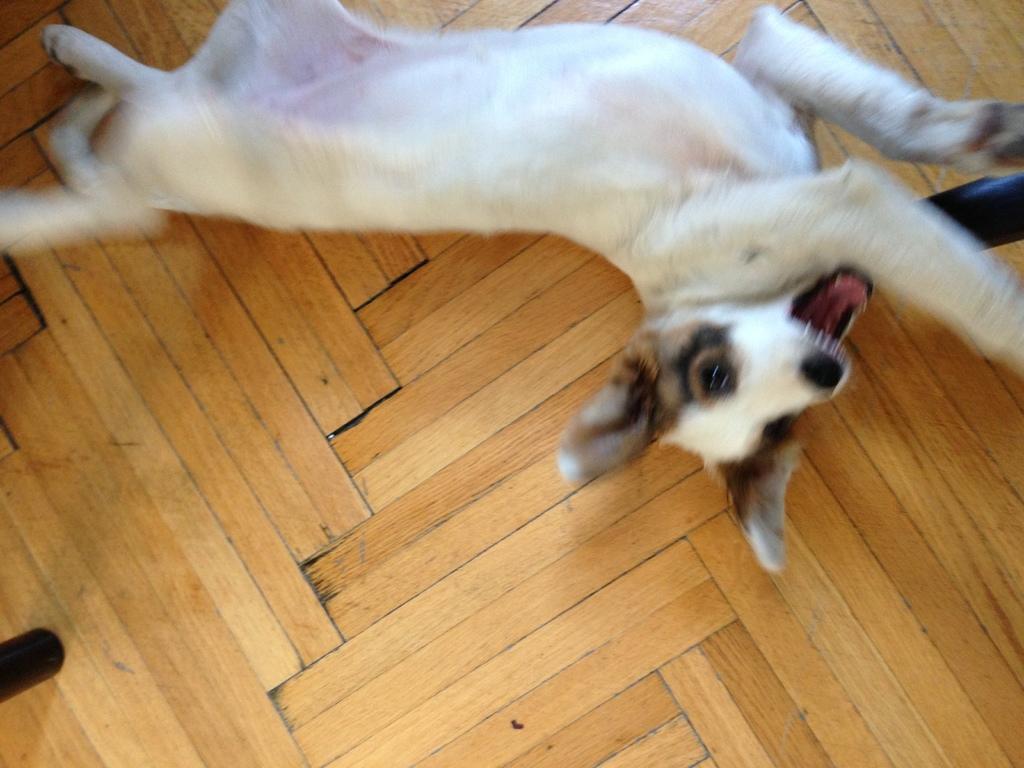How would you summarize this image in a sentence or two? In this image I can see the cream colored surface which is made up of wood and on it I can see a dog which is white, brown and black in color. I can see few other black colored objects. 